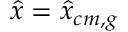<formula> <loc_0><loc_0><loc_500><loc_500>\hat { x } = \hat { x } _ { c m , g }</formula> 